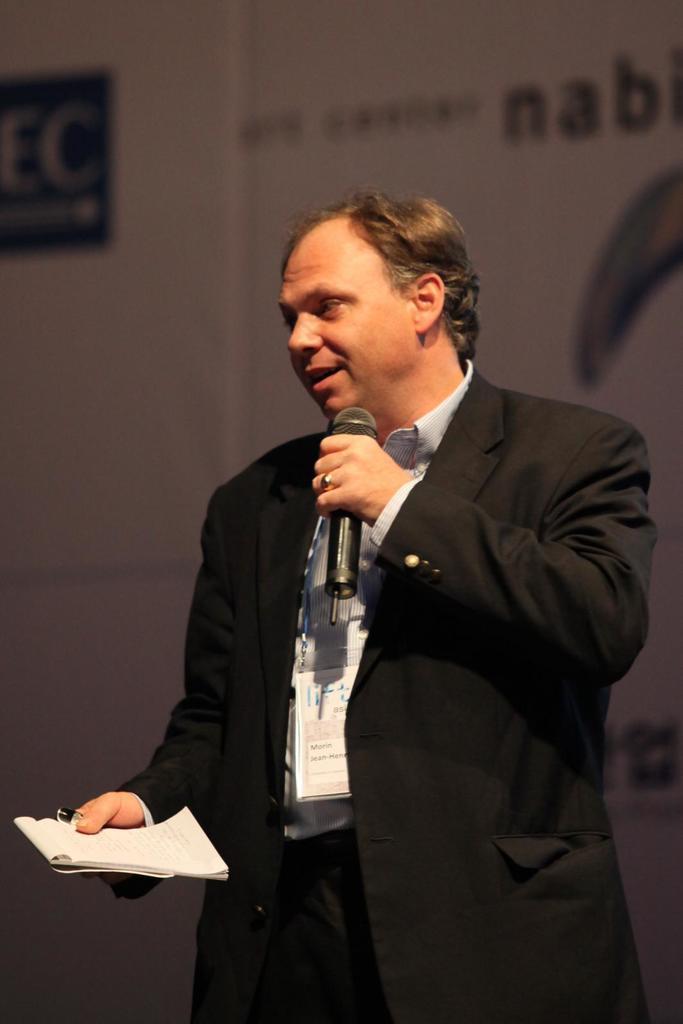Could you give a brief overview of what you see in this image? In this image there is one man who is standing and he is holding a book and mike, it seems that he is talking. 